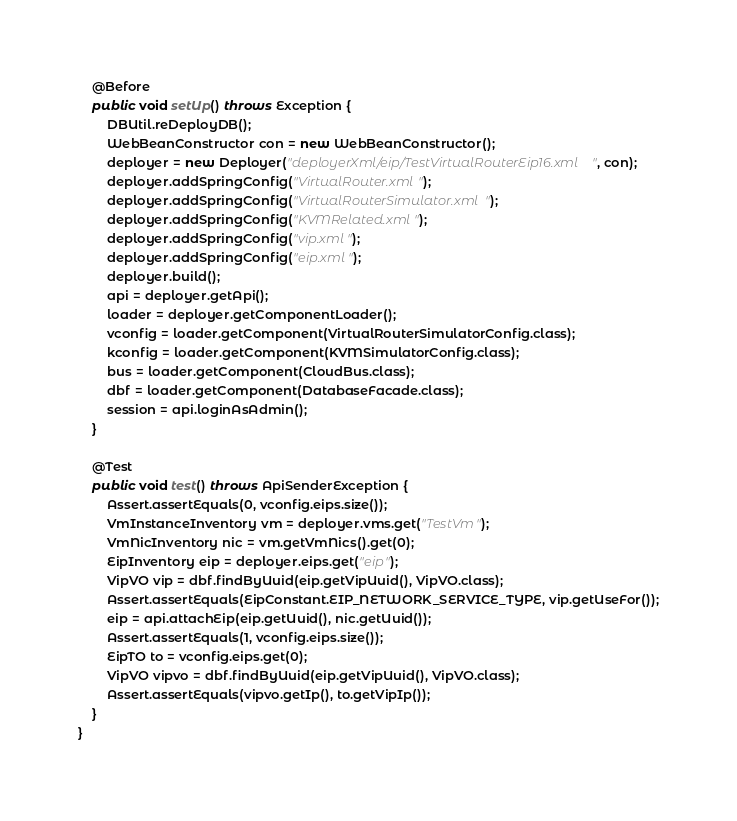<code> <loc_0><loc_0><loc_500><loc_500><_Java_>    @Before
    public void setUp() throws Exception {
        DBUtil.reDeployDB();
        WebBeanConstructor con = new WebBeanConstructor();
        deployer = new Deployer("deployerXml/eip/TestVirtualRouterEip16.xml", con);
        deployer.addSpringConfig("VirtualRouter.xml");
        deployer.addSpringConfig("VirtualRouterSimulator.xml");
        deployer.addSpringConfig("KVMRelated.xml");
        deployer.addSpringConfig("vip.xml");
        deployer.addSpringConfig("eip.xml");
        deployer.build();
        api = deployer.getApi();
        loader = deployer.getComponentLoader();
        vconfig = loader.getComponent(VirtualRouterSimulatorConfig.class);
        kconfig = loader.getComponent(KVMSimulatorConfig.class);
        bus = loader.getComponent(CloudBus.class);
        dbf = loader.getComponent(DatabaseFacade.class);
        session = api.loginAsAdmin();
    }

    @Test
    public void test() throws ApiSenderException {
        Assert.assertEquals(0, vconfig.eips.size());
        VmInstanceInventory vm = deployer.vms.get("TestVm");
        VmNicInventory nic = vm.getVmNics().get(0);
        EipInventory eip = deployer.eips.get("eip");
        VipVO vip = dbf.findByUuid(eip.getVipUuid(), VipVO.class);
        Assert.assertEquals(EipConstant.EIP_NETWORK_SERVICE_TYPE, vip.getUseFor());
        eip = api.attachEip(eip.getUuid(), nic.getUuid());
        Assert.assertEquals(1, vconfig.eips.size());
        EipTO to = vconfig.eips.get(0);
        VipVO vipvo = dbf.findByUuid(eip.getVipUuid(), VipVO.class);
        Assert.assertEquals(vipvo.getIp(), to.getVipIp());
    }
}
</code> 